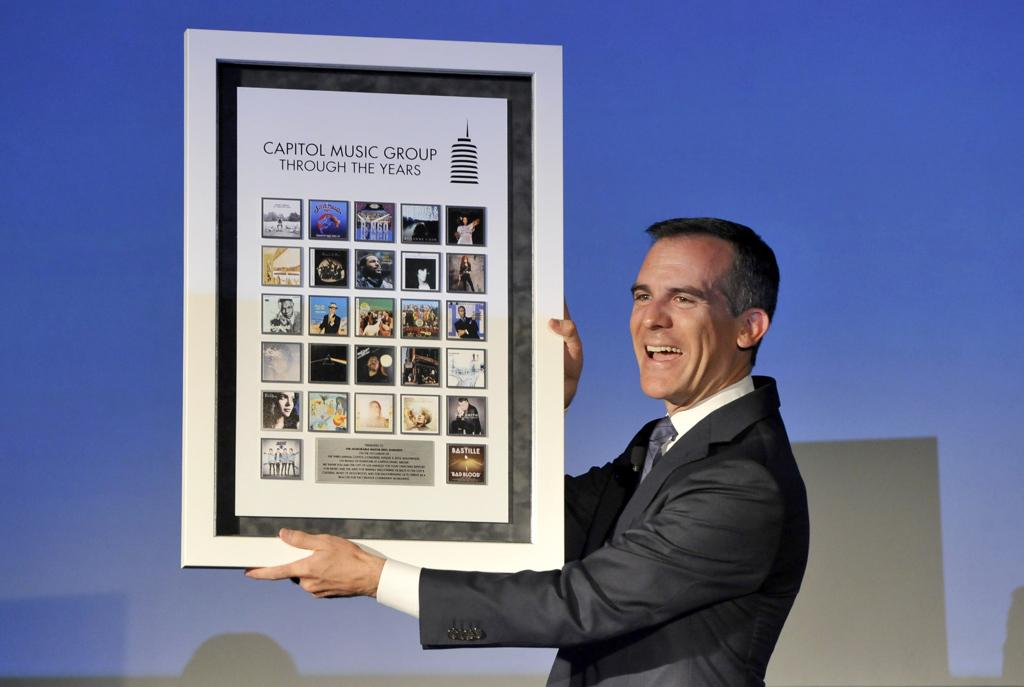<image>
Write a terse but informative summary of the picture. A man in a suit holding a poster showing differnt cover art for vaious music from Capitol Music group over the years. 